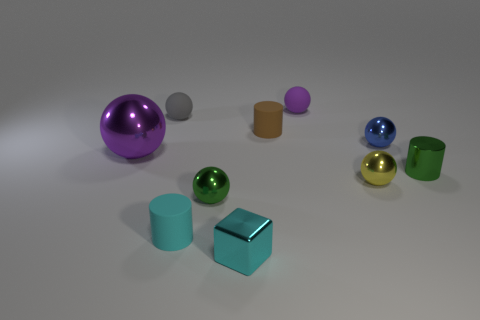What number of matte objects are both behind the small gray sphere and left of the block?
Your response must be concise. 0. What is the material of the gray object?
Your answer should be very brief. Rubber. How many objects are red cylinders or green metal spheres?
Your answer should be compact. 1. There is a green metallic object behind the small yellow object; does it have the same size as the green metallic thing on the left side of the cyan shiny block?
Provide a succinct answer. Yes. How many other objects are the same size as the green metal cylinder?
Your response must be concise. 8. How many objects are either tiny things behind the blue metal object or balls to the right of the yellow metal object?
Keep it short and to the point. 4. Does the cyan cylinder have the same material as the purple sphere that is on the left side of the green metallic ball?
Your response must be concise. No. How many other objects are the same shape as the tiny gray rubber thing?
Your response must be concise. 5. There is a purple sphere that is behind the tiny cylinder behind the purple thing to the left of the metal cube; what is its material?
Offer a terse response. Rubber. Is the number of tiny cyan cubes that are behind the cube the same as the number of tiny blue shiny objects?
Provide a succinct answer. No. 